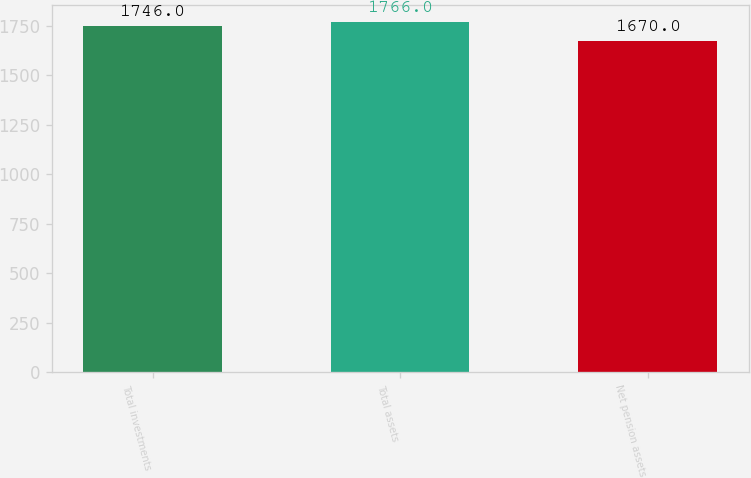Convert chart. <chart><loc_0><loc_0><loc_500><loc_500><bar_chart><fcel>Total investments<fcel>Total assets<fcel>Net pension assets<nl><fcel>1746<fcel>1766<fcel>1670<nl></chart> 